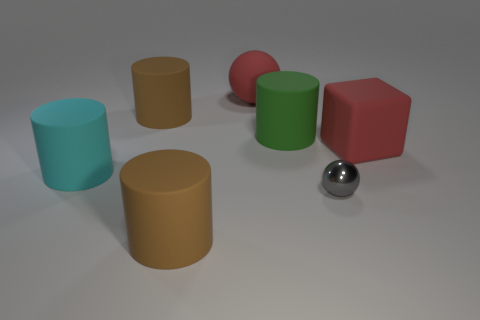Subtract all cyan matte cylinders. How many cylinders are left? 3 Add 2 large blue matte objects. How many objects exist? 9 Subtract all brown cylinders. How many cylinders are left? 2 Subtract all cubes. How many objects are left? 6 Subtract all gray cubes. How many purple cylinders are left? 0 Add 1 red rubber cubes. How many red rubber cubes exist? 2 Subtract 0 cyan balls. How many objects are left? 7 Subtract 2 balls. How many balls are left? 0 Subtract all yellow spheres. Subtract all brown cylinders. How many spheres are left? 2 Subtract all big brown cylinders. Subtract all big rubber cylinders. How many objects are left? 1 